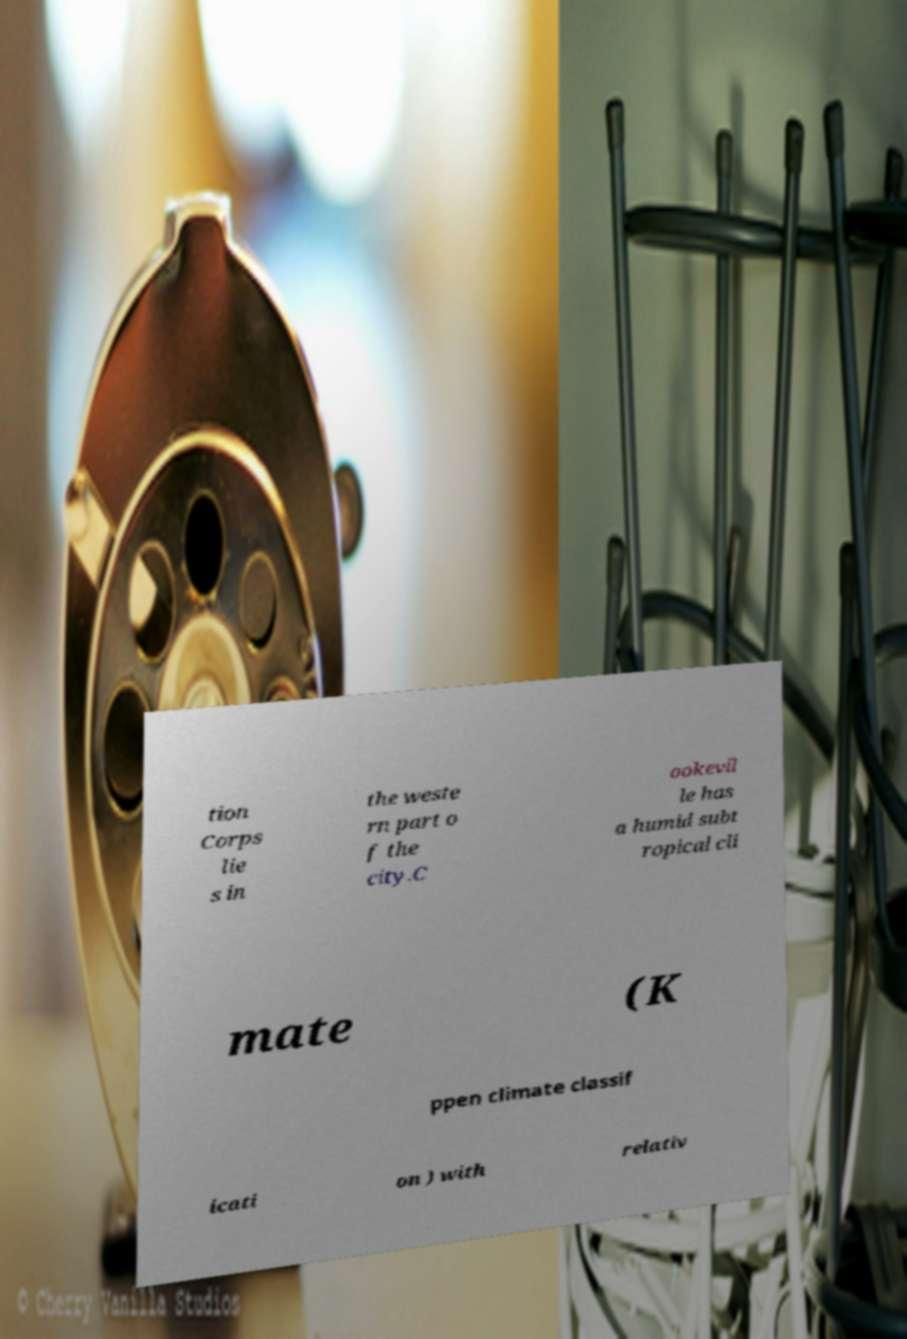What messages or text are displayed in this image? I need them in a readable, typed format. tion Corps lie s in the weste rn part o f the city.C ookevil le has a humid subt ropical cli mate (K ppen climate classif icati on ) with relativ 